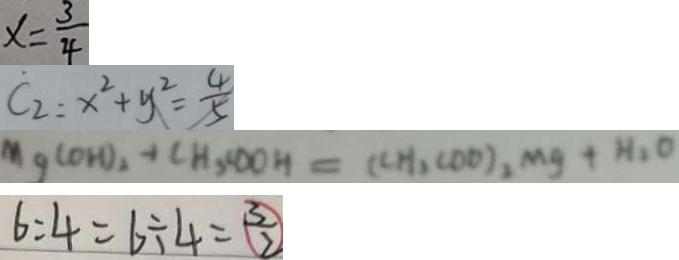Convert formula to latex. <formula><loc_0><loc_0><loc_500><loc_500>x = \frac { 3 } { 4 } 
 C _ { 2 } : x ^ { 2 } + y ^ { 2 } = \frac { 4 } { 5 } 
 M g ( O H ) _ { 2 } + C H _ { 3 } , C O O H = ( C H _ { 2 } C O O ) _ { 2 } M g + H _ { 2 } O 
 6 : 4 = 6 \div 4 = \frac { 3 } { 2 }</formula> 